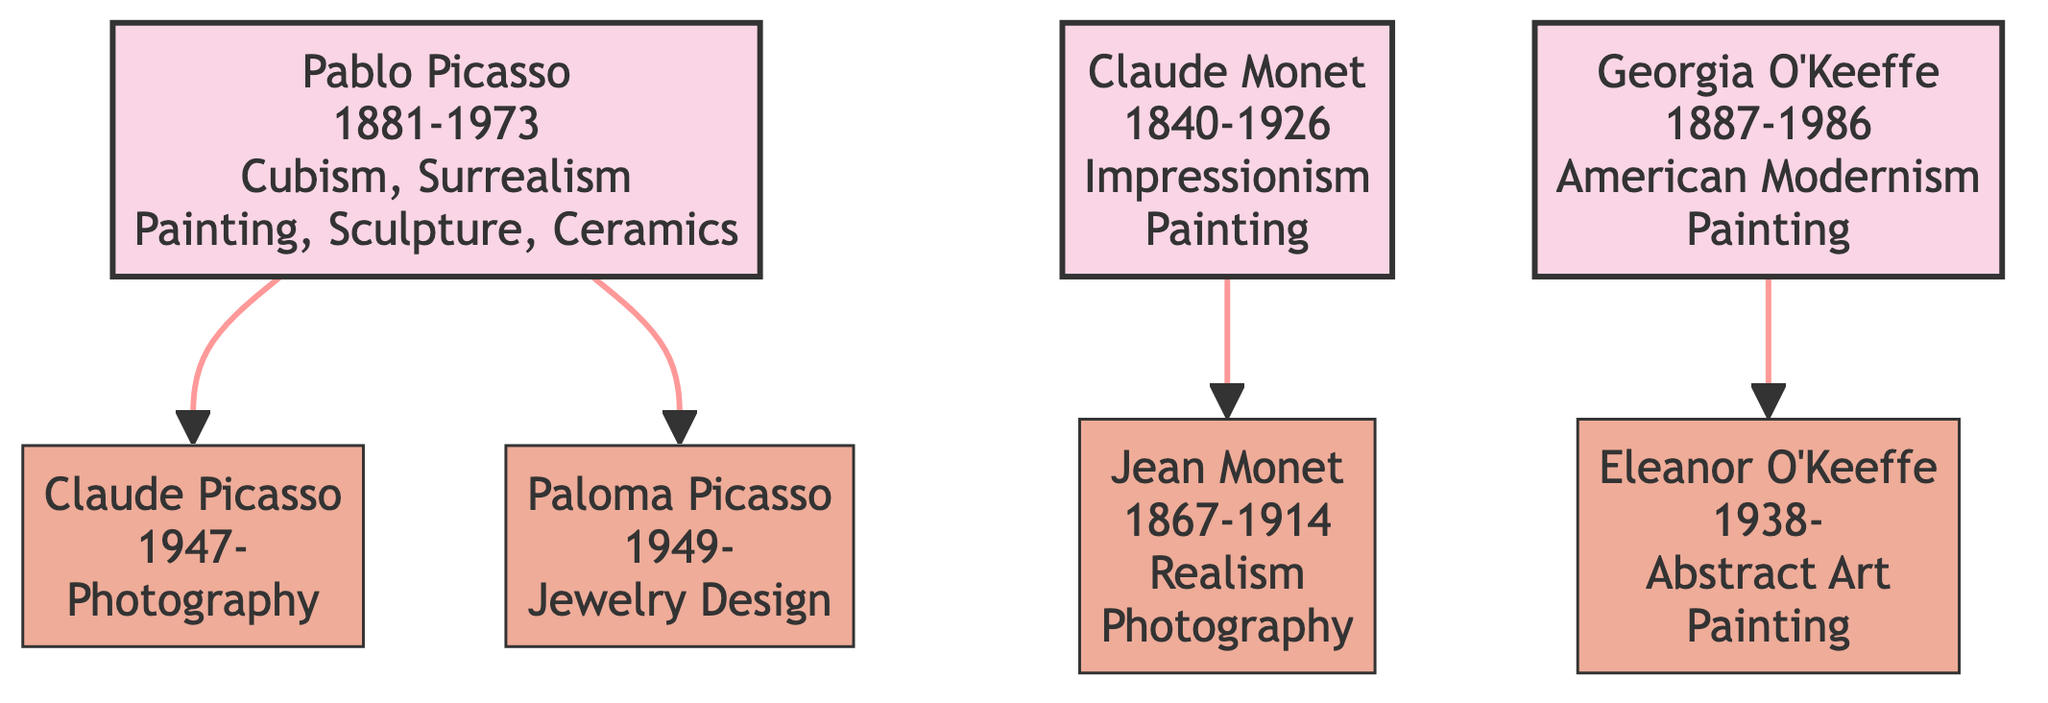What is the artistic style of Pablo Picasso? Pablo Picasso's node shows his name along with his birth and death years, and right below, the artistic style is listed as "Cubism, Surrealism".
Answer: Cubism, Surrealism How many children did Pablo Picasso have according to the diagram? The diagram shows two descendants branching from Pablo Picasso: Claude Picasso and Paloma Picasso. Thus, he has two children.
Answer: 2 Who is the descendant of Claude Monet? Below Claude Monet's node, there is one descendant node connected, which is Jean Monet. Therefore, Jean Monet is the descendant of Claude Monet.
Answer: Jean Monet What medium does Eleanor O'Keeffe use? In the diagram, Eleanor O'Keeffe's node specifies that her mediums include "Painting". This piece of information indicates her chosen medium.
Answer: Painting What is the relationship between Pablo Picasso and Claude Picasso? The diagram establishes a direct relationship between Pablo Picasso and Claude Picasso, where Claude is a descendant of Pablo. This connection can be inferred from the directional arrow connecting them.
Answer: Father-Son Which artist was born first, Georgia O'Keeffe or Pablo Picasso? By examining the birth years in the diagram, Pablo Picasso was born in 1881 and Georgia O'Keeffe was born in 1887. Since 1881 is earlier than 1887, Pablo Picasso was born first.
Answer: Pablo Picasso How many artistic styles are represented in the descendants of Pablo Picasso? Looking at the descendants of Pablo Picasso, Claude Picasso has "Photography" and Paloma Picasso has "Jewelry Design." This indicates that there are two distinct artistic styles represented among them.
Answer: 2 Identify the artist associated with Realism. The diagram shows that Jean Monet, through his connection as a descendant of Claude Monet, is explicitly stated to have "Realism" as his artistic style.
Answer: Jean Monet What is the artistic medium used by Paloma Picasso? In Paloma Picasso's node, her chosen medium is clearly specified as "Jewelry". Therefore, this is the artistic medium associated with her.
Answer: Jewelry 